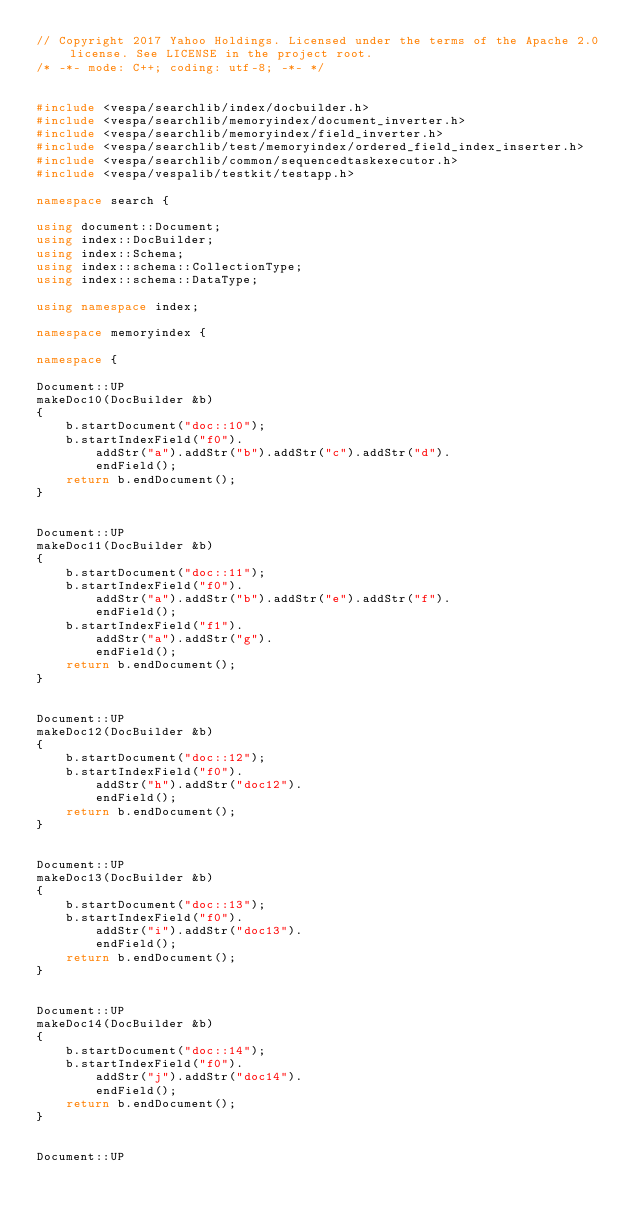Convert code to text. <code><loc_0><loc_0><loc_500><loc_500><_C++_>// Copyright 2017 Yahoo Holdings. Licensed under the terms of the Apache 2.0 license. See LICENSE in the project root.
/* -*- mode: C++; coding: utf-8; -*- */


#include <vespa/searchlib/index/docbuilder.h>
#include <vespa/searchlib/memoryindex/document_inverter.h>
#include <vespa/searchlib/memoryindex/field_inverter.h>
#include <vespa/searchlib/test/memoryindex/ordered_field_index_inserter.h>
#include <vespa/searchlib/common/sequencedtaskexecutor.h>
#include <vespa/vespalib/testkit/testapp.h>

namespace search {

using document::Document;
using index::DocBuilder;
using index::Schema;
using index::schema::CollectionType;
using index::schema::DataType;

using namespace index;

namespace memoryindex {

namespace {

Document::UP
makeDoc10(DocBuilder &b)
{
    b.startDocument("doc::10");
    b.startIndexField("f0").
        addStr("a").addStr("b").addStr("c").addStr("d").
        endField();
    return b.endDocument();
}


Document::UP
makeDoc11(DocBuilder &b)
{
    b.startDocument("doc::11");
    b.startIndexField("f0").
        addStr("a").addStr("b").addStr("e").addStr("f").
        endField();
    b.startIndexField("f1").
        addStr("a").addStr("g").
        endField();
    return b.endDocument();
}


Document::UP
makeDoc12(DocBuilder &b)
{
    b.startDocument("doc::12");
    b.startIndexField("f0").
        addStr("h").addStr("doc12").
        endField();
    return b.endDocument();
}


Document::UP
makeDoc13(DocBuilder &b)
{
    b.startDocument("doc::13");
    b.startIndexField("f0").
        addStr("i").addStr("doc13").
        endField();
    return b.endDocument();
}


Document::UP
makeDoc14(DocBuilder &b)
{
    b.startDocument("doc::14");
    b.startIndexField("f0").
        addStr("j").addStr("doc14").
        endField();
    return b.endDocument();
}


Document::UP</code> 